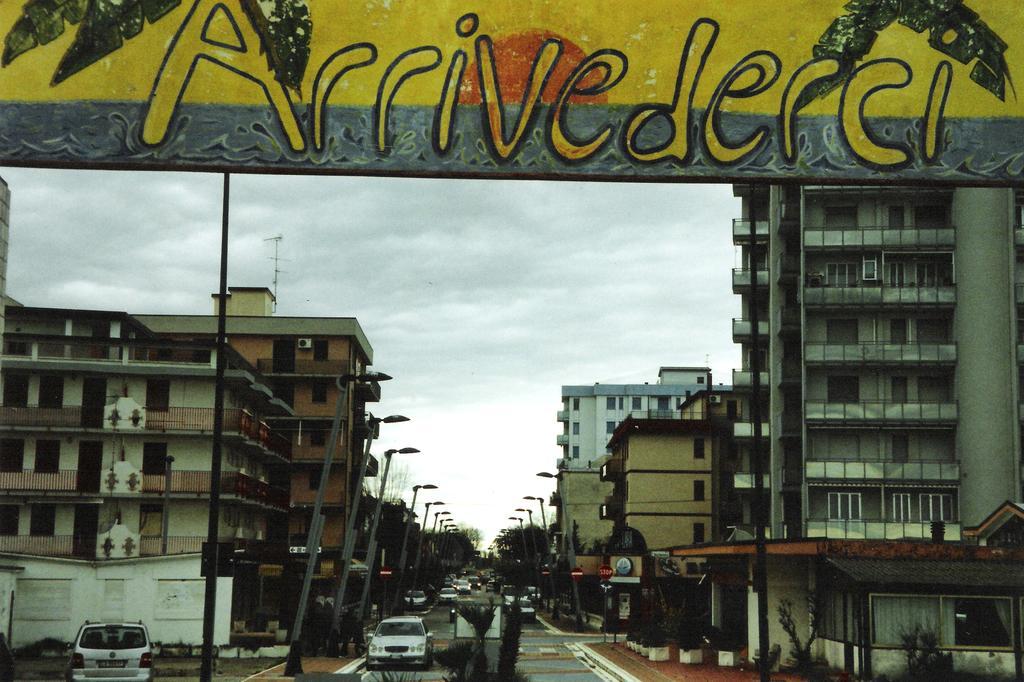Please provide a concise description of this image. In this picture I can see vehicles on the road, there are poles, lights, boards, there are buildings, there are trees, and in the background there is the sky. 